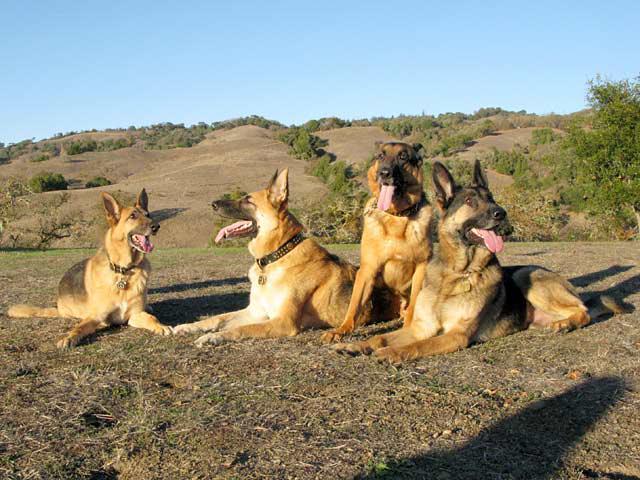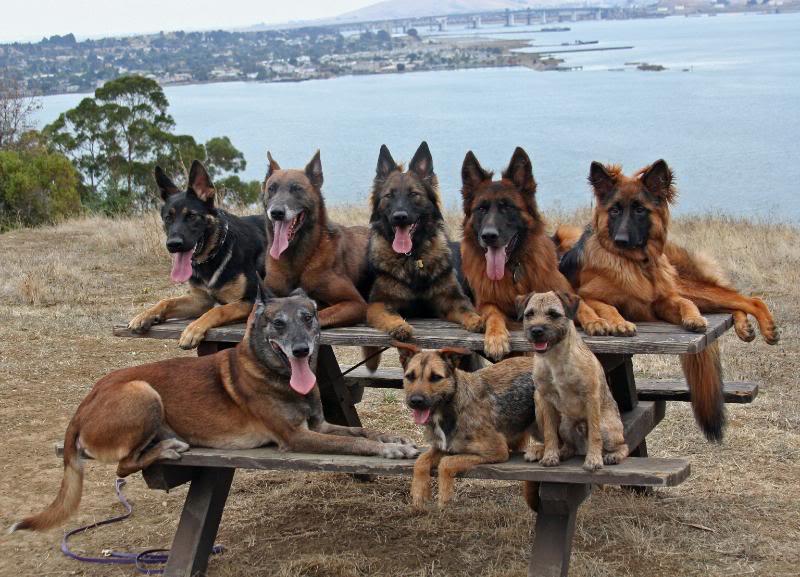The first image is the image on the left, the second image is the image on the right. For the images displayed, is the sentence "The left image includes three german shepherds with tongues out, in reclining poses with front paws extended and flat on the ground." factually correct? Answer yes or no. Yes. The first image is the image on the left, the second image is the image on the right. For the images displayed, is the sentence "An image shows dogs posed on a wooden bench." factually correct? Answer yes or no. Yes. The first image is the image on the left, the second image is the image on the right. For the images shown, is this caption "There are at most four dogs." true? Answer yes or no. No. 